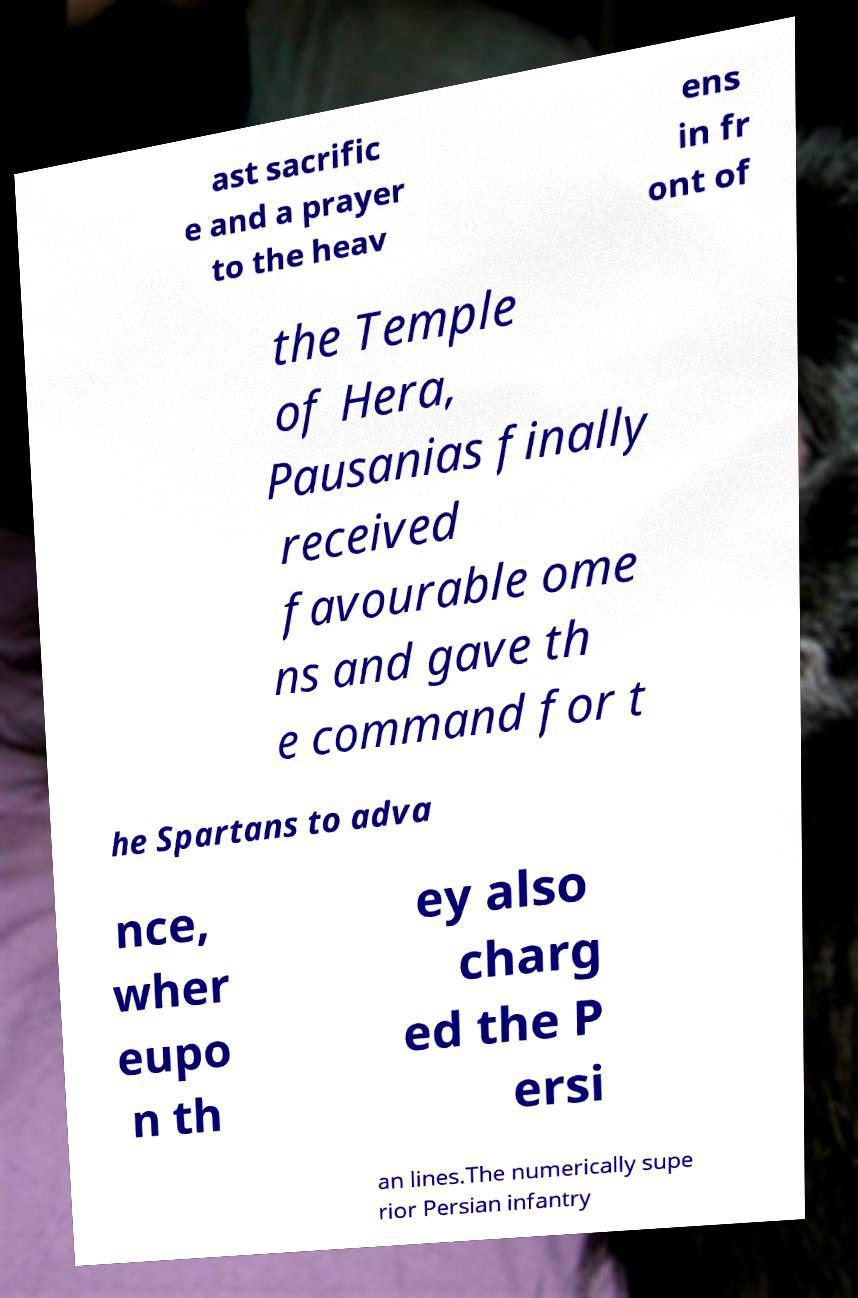I need the written content from this picture converted into text. Can you do that? ast sacrific e and a prayer to the heav ens in fr ont of the Temple of Hera, Pausanias finally received favourable ome ns and gave th e command for t he Spartans to adva nce, wher eupo n th ey also charg ed the P ersi an lines.The numerically supe rior Persian infantry 